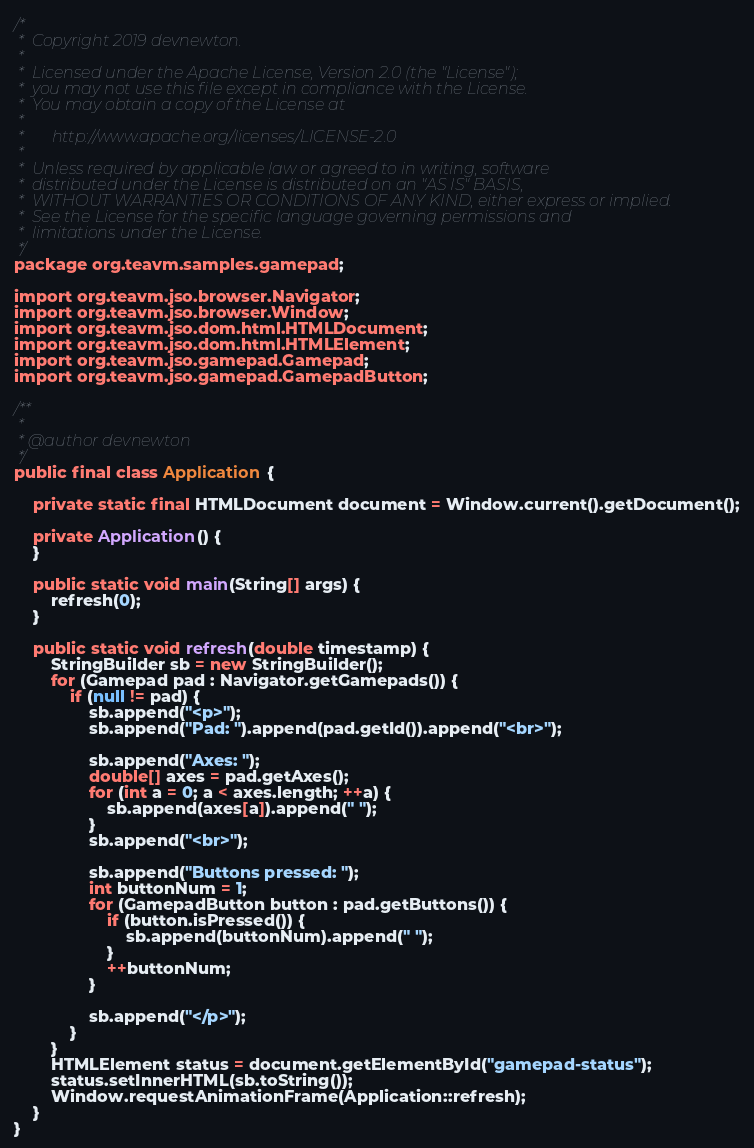<code> <loc_0><loc_0><loc_500><loc_500><_Java_>/*
 *  Copyright 2019 devnewton.
 *
 *  Licensed under the Apache License, Version 2.0 (the "License");
 *  you may not use this file except in compliance with the License.
 *  You may obtain a copy of the License at
 *
 *       http://www.apache.org/licenses/LICENSE-2.0
 *
 *  Unless required by applicable law or agreed to in writing, software
 *  distributed under the License is distributed on an "AS IS" BASIS,
 *  WITHOUT WARRANTIES OR CONDITIONS OF ANY KIND, either express or implied.
 *  See the License for the specific language governing permissions and
 *  limitations under the License.
 */
package org.teavm.samples.gamepad;

import org.teavm.jso.browser.Navigator;
import org.teavm.jso.browser.Window;
import org.teavm.jso.dom.html.HTMLDocument;
import org.teavm.jso.dom.html.HTMLElement;
import org.teavm.jso.gamepad.Gamepad;
import org.teavm.jso.gamepad.GamepadButton;

/**
 *
 * @author devnewton
 */
public final class Application {

    private static final HTMLDocument document = Window.current().getDocument();

    private Application() {
    }

    public static void main(String[] args) {
        refresh(0);
    }

    public static void refresh(double timestamp) {
        StringBuilder sb = new StringBuilder();
        for (Gamepad pad : Navigator.getGamepads()) {
            if (null != pad) {
                sb.append("<p>");
                sb.append("Pad: ").append(pad.getId()).append("<br>");

                sb.append("Axes: ");
                double[] axes = pad.getAxes();
                for (int a = 0; a < axes.length; ++a) {
                    sb.append(axes[a]).append(" ");
                }
                sb.append("<br>");

                sb.append("Buttons pressed: ");
                int buttonNum = 1;
                for (GamepadButton button : pad.getButtons()) {
                    if (button.isPressed()) {
                        sb.append(buttonNum).append(" ");
                    }
                    ++buttonNum;
                }

                sb.append("</p>");
            }
        }
        HTMLElement status = document.getElementById("gamepad-status");
        status.setInnerHTML(sb.toString());
        Window.requestAnimationFrame(Application::refresh);
    }
}
</code> 